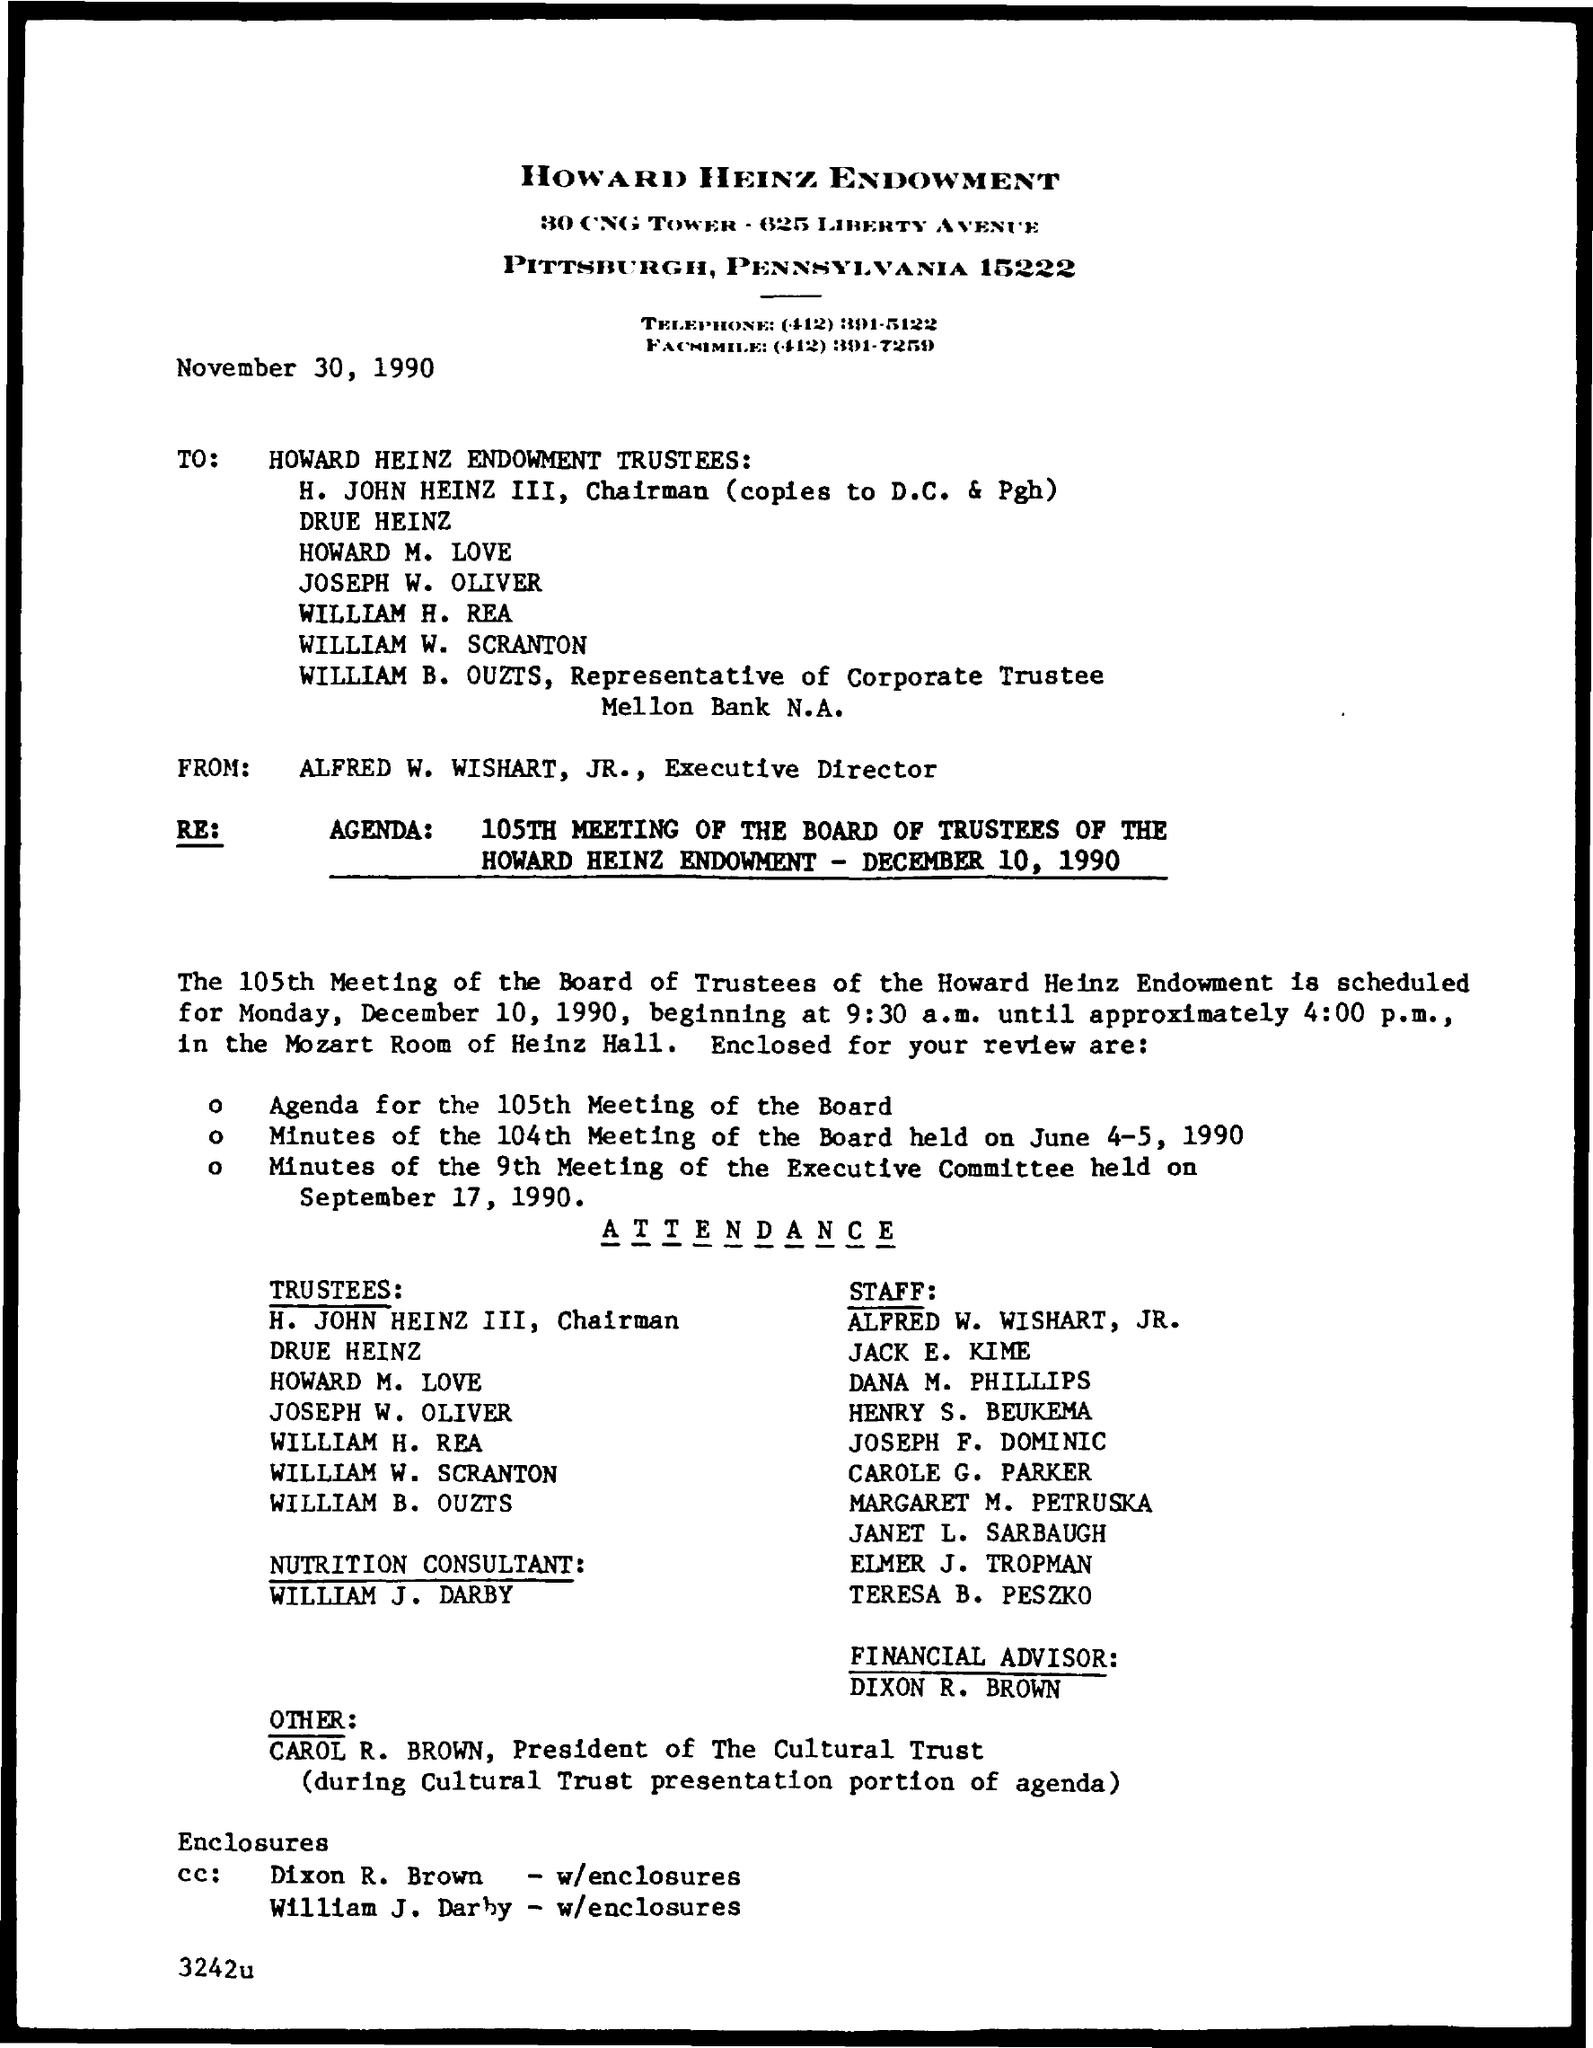Point out several critical features in this image. The chairman of the company is H. John Heinz III. 